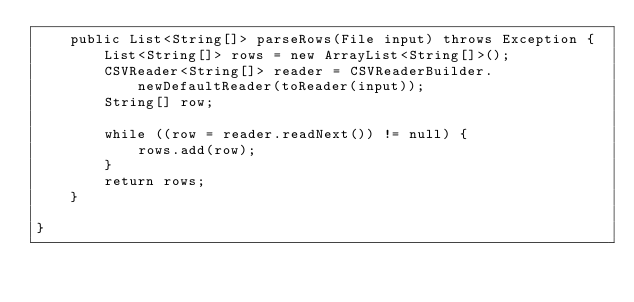<code> <loc_0><loc_0><loc_500><loc_500><_Java_>	public List<String[]> parseRows(File input) throws Exception {
		List<String[]> rows = new ArrayList<String[]>();
		CSVReader<String[]> reader = CSVReaderBuilder.newDefaultReader(toReader(input));
		String[] row;

		while ((row = reader.readNext()) != null) {
			rows.add(row);
		}
		return rows;
	}

}
</code> 